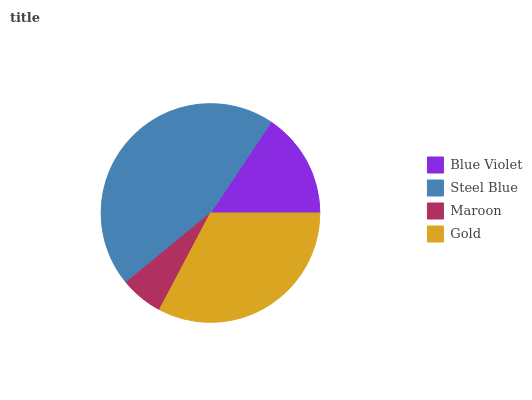Is Maroon the minimum?
Answer yes or no. Yes. Is Steel Blue the maximum?
Answer yes or no. Yes. Is Steel Blue the minimum?
Answer yes or no. No. Is Maroon the maximum?
Answer yes or no. No. Is Steel Blue greater than Maroon?
Answer yes or no. Yes. Is Maroon less than Steel Blue?
Answer yes or no. Yes. Is Maroon greater than Steel Blue?
Answer yes or no. No. Is Steel Blue less than Maroon?
Answer yes or no. No. Is Gold the high median?
Answer yes or no. Yes. Is Blue Violet the low median?
Answer yes or no. Yes. Is Blue Violet the high median?
Answer yes or no. No. Is Gold the low median?
Answer yes or no. No. 